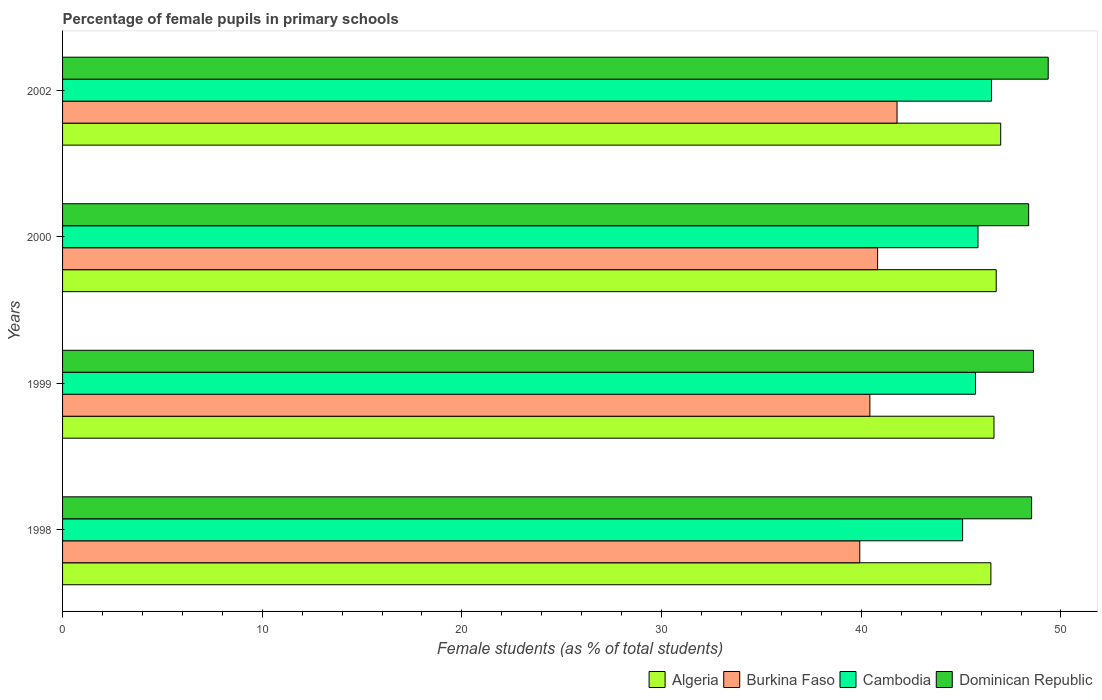How many groups of bars are there?
Your answer should be compact. 4. Are the number of bars on each tick of the Y-axis equal?
Your response must be concise. Yes. How many bars are there on the 2nd tick from the bottom?
Your answer should be compact. 4. In how many cases, is the number of bars for a given year not equal to the number of legend labels?
Give a very brief answer. 0. What is the percentage of female pupils in primary schools in Cambodia in 1999?
Give a very brief answer. 45.72. Across all years, what is the maximum percentage of female pupils in primary schools in Algeria?
Provide a short and direct response. 46.98. Across all years, what is the minimum percentage of female pupils in primary schools in Algeria?
Make the answer very short. 46.49. In which year was the percentage of female pupils in primary schools in Cambodia maximum?
Your response must be concise. 2002. In which year was the percentage of female pupils in primary schools in Burkina Faso minimum?
Your answer should be compact. 1998. What is the total percentage of female pupils in primary schools in Burkina Faso in the graph?
Make the answer very short. 162.97. What is the difference between the percentage of female pupils in primary schools in Cambodia in 1998 and that in 2000?
Provide a succinct answer. -0.77. What is the difference between the percentage of female pupils in primary schools in Algeria in 1998 and the percentage of female pupils in primary schools in Burkina Faso in 1999?
Offer a terse response. 6.06. What is the average percentage of female pupils in primary schools in Dominican Republic per year?
Offer a very short reply. 48.72. In the year 1999, what is the difference between the percentage of female pupils in primary schools in Burkina Faso and percentage of female pupils in primary schools in Algeria?
Your answer should be very brief. -6.21. What is the ratio of the percentage of female pupils in primary schools in Burkina Faso in 1999 to that in 2002?
Provide a succinct answer. 0.97. What is the difference between the highest and the second highest percentage of female pupils in primary schools in Algeria?
Give a very brief answer. 0.23. What is the difference between the highest and the lowest percentage of female pupils in primary schools in Algeria?
Your answer should be compact. 0.49. Is the sum of the percentage of female pupils in primary schools in Cambodia in 2000 and 2002 greater than the maximum percentage of female pupils in primary schools in Algeria across all years?
Your answer should be very brief. Yes. What does the 4th bar from the top in 2002 represents?
Your response must be concise. Algeria. What does the 3rd bar from the bottom in 2002 represents?
Make the answer very short. Cambodia. Is it the case that in every year, the sum of the percentage of female pupils in primary schools in Dominican Republic and percentage of female pupils in primary schools in Burkina Faso is greater than the percentage of female pupils in primary schools in Cambodia?
Keep it short and to the point. Yes. How many bars are there?
Give a very brief answer. 16. How many years are there in the graph?
Your answer should be compact. 4. Are the values on the major ticks of X-axis written in scientific E-notation?
Make the answer very short. No. Does the graph contain any zero values?
Give a very brief answer. No. Does the graph contain grids?
Your answer should be very brief. No. Where does the legend appear in the graph?
Your answer should be compact. Bottom right. What is the title of the graph?
Offer a very short reply. Percentage of female pupils in primary schools. Does "Ethiopia" appear as one of the legend labels in the graph?
Offer a terse response. No. What is the label or title of the X-axis?
Provide a short and direct response. Female students (as % of total students). What is the Female students (as % of total students) in Algeria in 1998?
Ensure brevity in your answer.  46.49. What is the Female students (as % of total students) in Burkina Faso in 1998?
Give a very brief answer. 39.93. What is the Female students (as % of total students) of Cambodia in 1998?
Your response must be concise. 45.08. What is the Female students (as % of total students) of Dominican Republic in 1998?
Make the answer very short. 48.53. What is the Female students (as % of total students) of Algeria in 1999?
Provide a succinct answer. 46.65. What is the Female students (as % of total students) in Burkina Faso in 1999?
Provide a short and direct response. 40.43. What is the Female students (as % of total students) of Cambodia in 1999?
Keep it short and to the point. 45.72. What is the Female students (as % of total students) in Dominican Republic in 1999?
Make the answer very short. 48.62. What is the Female students (as % of total students) of Algeria in 2000?
Your response must be concise. 46.76. What is the Female students (as % of total students) of Burkina Faso in 2000?
Keep it short and to the point. 40.82. What is the Female students (as % of total students) in Cambodia in 2000?
Give a very brief answer. 45.85. What is the Female students (as % of total students) in Dominican Republic in 2000?
Make the answer very short. 48.38. What is the Female students (as % of total students) of Algeria in 2002?
Give a very brief answer. 46.98. What is the Female students (as % of total students) in Burkina Faso in 2002?
Provide a succinct answer. 41.79. What is the Female students (as % of total students) of Cambodia in 2002?
Your response must be concise. 46.52. What is the Female students (as % of total students) of Dominican Republic in 2002?
Offer a terse response. 49.36. Across all years, what is the maximum Female students (as % of total students) in Algeria?
Offer a terse response. 46.98. Across all years, what is the maximum Female students (as % of total students) in Burkina Faso?
Keep it short and to the point. 41.79. Across all years, what is the maximum Female students (as % of total students) in Cambodia?
Provide a short and direct response. 46.52. Across all years, what is the maximum Female students (as % of total students) of Dominican Republic?
Offer a very short reply. 49.36. Across all years, what is the minimum Female students (as % of total students) in Algeria?
Your answer should be very brief. 46.49. Across all years, what is the minimum Female students (as % of total students) in Burkina Faso?
Keep it short and to the point. 39.93. Across all years, what is the minimum Female students (as % of total students) of Cambodia?
Offer a very short reply. 45.08. Across all years, what is the minimum Female students (as % of total students) of Dominican Republic?
Provide a short and direct response. 48.38. What is the total Female students (as % of total students) of Algeria in the graph?
Keep it short and to the point. 186.88. What is the total Female students (as % of total students) in Burkina Faso in the graph?
Provide a short and direct response. 162.97. What is the total Female students (as % of total students) in Cambodia in the graph?
Make the answer very short. 183.17. What is the total Female students (as % of total students) of Dominican Republic in the graph?
Make the answer very short. 194.9. What is the difference between the Female students (as % of total students) in Algeria in 1998 and that in 1999?
Your answer should be compact. -0.15. What is the difference between the Female students (as % of total students) of Burkina Faso in 1998 and that in 1999?
Your answer should be compact. -0.51. What is the difference between the Female students (as % of total students) of Cambodia in 1998 and that in 1999?
Your answer should be very brief. -0.65. What is the difference between the Female students (as % of total students) in Dominican Republic in 1998 and that in 1999?
Offer a very short reply. -0.09. What is the difference between the Female students (as % of total students) of Algeria in 1998 and that in 2000?
Provide a short and direct response. -0.27. What is the difference between the Female students (as % of total students) in Burkina Faso in 1998 and that in 2000?
Offer a very short reply. -0.89. What is the difference between the Female students (as % of total students) in Cambodia in 1998 and that in 2000?
Provide a succinct answer. -0.77. What is the difference between the Female students (as % of total students) of Dominican Republic in 1998 and that in 2000?
Make the answer very short. 0.15. What is the difference between the Female students (as % of total students) of Algeria in 1998 and that in 2002?
Offer a terse response. -0.49. What is the difference between the Female students (as % of total students) in Burkina Faso in 1998 and that in 2002?
Offer a very short reply. -1.87. What is the difference between the Female students (as % of total students) of Cambodia in 1998 and that in 2002?
Offer a very short reply. -1.45. What is the difference between the Female students (as % of total students) of Dominican Republic in 1998 and that in 2002?
Offer a terse response. -0.83. What is the difference between the Female students (as % of total students) in Algeria in 1999 and that in 2000?
Offer a terse response. -0.11. What is the difference between the Female students (as % of total students) in Burkina Faso in 1999 and that in 2000?
Provide a succinct answer. -0.39. What is the difference between the Female students (as % of total students) in Cambodia in 1999 and that in 2000?
Ensure brevity in your answer.  -0.12. What is the difference between the Female students (as % of total students) of Dominican Republic in 1999 and that in 2000?
Provide a succinct answer. 0.24. What is the difference between the Female students (as % of total students) in Algeria in 1999 and that in 2002?
Give a very brief answer. -0.34. What is the difference between the Female students (as % of total students) of Burkina Faso in 1999 and that in 2002?
Provide a short and direct response. -1.36. What is the difference between the Female students (as % of total students) of Cambodia in 1999 and that in 2002?
Keep it short and to the point. -0.8. What is the difference between the Female students (as % of total students) in Dominican Republic in 1999 and that in 2002?
Your answer should be very brief. -0.74. What is the difference between the Female students (as % of total students) of Algeria in 2000 and that in 2002?
Your answer should be compact. -0.23. What is the difference between the Female students (as % of total students) in Burkina Faso in 2000 and that in 2002?
Keep it short and to the point. -0.97. What is the difference between the Female students (as % of total students) of Cambodia in 2000 and that in 2002?
Offer a terse response. -0.68. What is the difference between the Female students (as % of total students) of Dominican Republic in 2000 and that in 2002?
Offer a terse response. -0.98. What is the difference between the Female students (as % of total students) of Algeria in 1998 and the Female students (as % of total students) of Burkina Faso in 1999?
Provide a succinct answer. 6.06. What is the difference between the Female students (as % of total students) of Algeria in 1998 and the Female students (as % of total students) of Cambodia in 1999?
Give a very brief answer. 0.77. What is the difference between the Female students (as % of total students) in Algeria in 1998 and the Female students (as % of total students) in Dominican Republic in 1999?
Keep it short and to the point. -2.13. What is the difference between the Female students (as % of total students) of Burkina Faso in 1998 and the Female students (as % of total students) of Cambodia in 1999?
Keep it short and to the point. -5.8. What is the difference between the Female students (as % of total students) of Burkina Faso in 1998 and the Female students (as % of total students) of Dominican Republic in 1999?
Your answer should be compact. -8.7. What is the difference between the Female students (as % of total students) in Cambodia in 1998 and the Female students (as % of total students) in Dominican Republic in 1999?
Provide a succinct answer. -3.55. What is the difference between the Female students (as % of total students) of Algeria in 1998 and the Female students (as % of total students) of Burkina Faso in 2000?
Your answer should be compact. 5.67. What is the difference between the Female students (as % of total students) of Algeria in 1998 and the Female students (as % of total students) of Cambodia in 2000?
Provide a succinct answer. 0.65. What is the difference between the Female students (as % of total students) in Algeria in 1998 and the Female students (as % of total students) in Dominican Republic in 2000?
Keep it short and to the point. -1.89. What is the difference between the Female students (as % of total students) in Burkina Faso in 1998 and the Female students (as % of total students) in Cambodia in 2000?
Give a very brief answer. -5.92. What is the difference between the Female students (as % of total students) of Burkina Faso in 1998 and the Female students (as % of total students) of Dominican Republic in 2000?
Give a very brief answer. -8.46. What is the difference between the Female students (as % of total students) in Cambodia in 1998 and the Female students (as % of total students) in Dominican Republic in 2000?
Your answer should be very brief. -3.31. What is the difference between the Female students (as % of total students) of Algeria in 1998 and the Female students (as % of total students) of Burkina Faso in 2002?
Provide a succinct answer. 4.7. What is the difference between the Female students (as % of total students) of Algeria in 1998 and the Female students (as % of total students) of Cambodia in 2002?
Offer a very short reply. -0.03. What is the difference between the Female students (as % of total students) in Algeria in 1998 and the Female students (as % of total students) in Dominican Republic in 2002?
Offer a very short reply. -2.87. What is the difference between the Female students (as % of total students) in Burkina Faso in 1998 and the Female students (as % of total students) in Cambodia in 2002?
Give a very brief answer. -6.6. What is the difference between the Female students (as % of total students) in Burkina Faso in 1998 and the Female students (as % of total students) in Dominican Republic in 2002?
Offer a very short reply. -9.44. What is the difference between the Female students (as % of total students) in Cambodia in 1998 and the Female students (as % of total students) in Dominican Republic in 2002?
Offer a terse response. -4.29. What is the difference between the Female students (as % of total students) of Algeria in 1999 and the Female students (as % of total students) of Burkina Faso in 2000?
Your answer should be very brief. 5.83. What is the difference between the Female students (as % of total students) in Algeria in 1999 and the Female students (as % of total students) in Cambodia in 2000?
Keep it short and to the point. 0.8. What is the difference between the Female students (as % of total students) in Algeria in 1999 and the Female students (as % of total students) in Dominican Republic in 2000?
Make the answer very short. -1.74. What is the difference between the Female students (as % of total students) in Burkina Faso in 1999 and the Female students (as % of total students) in Cambodia in 2000?
Your answer should be compact. -5.41. What is the difference between the Female students (as % of total students) in Burkina Faso in 1999 and the Female students (as % of total students) in Dominican Republic in 2000?
Make the answer very short. -7.95. What is the difference between the Female students (as % of total students) in Cambodia in 1999 and the Female students (as % of total students) in Dominican Republic in 2000?
Keep it short and to the point. -2.66. What is the difference between the Female students (as % of total students) in Algeria in 1999 and the Female students (as % of total students) in Burkina Faso in 2002?
Give a very brief answer. 4.85. What is the difference between the Female students (as % of total students) in Algeria in 1999 and the Female students (as % of total students) in Cambodia in 2002?
Provide a succinct answer. 0.12. What is the difference between the Female students (as % of total students) of Algeria in 1999 and the Female students (as % of total students) of Dominican Republic in 2002?
Offer a very short reply. -2.72. What is the difference between the Female students (as % of total students) of Burkina Faso in 1999 and the Female students (as % of total students) of Cambodia in 2002?
Ensure brevity in your answer.  -6.09. What is the difference between the Female students (as % of total students) of Burkina Faso in 1999 and the Female students (as % of total students) of Dominican Republic in 2002?
Provide a succinct answer. -8.93. What is the difference between the Female students (as % of total students) in Cambodia in 1999 and the Female students (as % of total students) in Dominican Republic in 2002?
Keep it short and to the point. -3.64. What is the difference between the Female students (as % of total students) of Algeria in 2000 and the Female students (as % of total students) of Burkina Faso in 2002?
Your response must be concise. 4.97. What is the difference between the Female students (as % of total students) of Algeria in 2000 and the Female students (as % of total students) of Cambodia in 2002?
Make the answer very short. 0.24. What is the difference between the Female students (as % of total students) of Algeria in 2000 and the Female students (as % of total students) of Dominican Republic in 2002?
Ensure brevity in your answer.  -2.6. What is the difference between the Female students (as % of total students) in Burkina Faso in 2000 and the Female students (as % of total students) in Cambodia in 2002?
Offer a terse response. -5.7. What is the difference between the Female students (as % of total students) of Burkina Faso in 2000 and the Female students (as % of total students) of Dominican Republic in 2002?
Your answer should be compact. -8.54. What is the difference between the Female students (as % of total students) in Cambodia in 2000 and the Female students (as % of total students) in Dominican Republic in 2002?
Make the answer very short. -3.52. What is the average Female students (as % of total students) in Algeria per year?
Ensure brevity in your answer.  46.72. What is the average Female students (as % of total students) in Burkina Faso per year?
Your response must be concise. 40.74. What is the average Female students (as % of total students) in Cambodia per year?
Ensure brevity in your answer.  45.79. What is the average Female students (as % of total students) in Dominican Republic per year?
Your answer should be very brief. 48.72. In the year 1998, what is the difference between the Female students (as % of total students) of Algeria and Female students (as % of total students) of Burkina Faso?
Your answer should be compact. 6.57. In the year 1998, what is the difference between the Female students (as % of total students) of Algeria and Female students (as % of total students) of Cambodia?
Keep it short and to the point. 1.42. In the year 1998, what is the difference between the Female students (as % of total students) in Algeria and Female students (as % of total students) in Dominican Republic?
Give a very brief answer. -2.04. In the year 1998, what is the difference between the Female students (as % of total students) in Burkina Faso and Female students (as % of total students) in Cambodia?
Ensure brevity in your answer.  -5.15. In the year 1998, what is the difference between the Female students (as % of total students) of Burkina Faso and Female students (as % of total students) of Dominican Republic?
Offer a very short reply. -8.61. In the year 1998, what is the difference between the Female students (as % of total students) of Cambodia and Female students (as % of total students) of Dominican Republic?
Keep it short and to the point. -3.45. In the year 1999, what is the difference between the Female students (as % of total students) in Algeria and Female students (as % of total students) in Burkina Faso?
Make the answer very short. 6.21. In the year 1999, what is the difference between the Female students (as % of total students) of Algeria and Female students (as % of total students) of Cambodia?
Your answer should be very brief. 0.92. In the year 1999, what is the difference between the Female students (as % of total students) in Algeria and Female students (as % of total students) in Dominican Republic?
Offer a very short reply. -1.98. In the year 1999, what is the difference between the Female students (as % of total students) in Burkina Faso and Female students (as % of total students) in Cambodia?
Ensure brevity in your answer.  -5.29. In the year 1999, what is the difference between the Female students (as % of total students) of Burkina Faso and Female students (as % of total students) of Dominican Republic?
Keep it short and to the point. -8.19. In the year 1999, what is the difference between the Female students (as % of total students) in Cambodia and Female students (as % of total students) in Dominican Republic?
Ensure brevity in your answer.  -2.9. In the year 2000, what is the difference between the Female students (as % of total students) in Algeria and Female students (as % of total students) in Burkina Faso?
Give a very brief answer. 5.94. In the year 2000, what is the difference between the Female students (as % of total students) of Algeria and Female students (as % of total students) of Cambodia?
Provide a short and direct response. 0.91. In the year 2000, what is the difference between the Female students (as % of total students) of Algeria and Female students (as % of total students) of Dominican Republic?
Offer a very short reply. -1.62. In the year 2000, what is the difference between the Female students (as % of total students) of Burkina Faso and Female students (as % of total students) of Cambodia?
Ensure brevity in your answer.  -5.03. In the year 2000, what is the difference between the Female students (as % of total students) in Burkina Faso and Female students (as % of total students) in Dominican Republic?
Offer a very short reply. -7.56. In the year 2000, what is the difference between the Female students (as % of total students) in Cambodia and Female students (as % of total students) in Dominican Republic?
Offer a very short reply. -2.54. In the year 2002, what is the difference between the Female students (as % of total students) of Algeria and Female students (as % of total students) of Burkina Faso?
Make the answer very short. 5.19. In the year 2002, what is the difference between the Female students (as % of total students) in Algeria and Female students (as % of total students) in Cambodia?
Provide a succinct answer. 0.46. In the year 2002, what is the difference between the Female students (as % of total students) in Algeria and Female students (as % of total students) in Dominican Republic?
Ensure brevity in your answer.  -2.38. In the year 2002, what is the difference between the Female students (as % of total students) of Burkina Faso and Female students (as % of total students) of Cambodia?
Make the answer very short. -4.73. In the year 2002, what is the difference between the Female students (as % of total students) of Burkina Faso and Female students (as % of total students) of Dominican Republic?
Ensure brevity in your answer.  -7.57. In the year 2002, what is the difference between the Female students (as % of total students) of Cambodia and Female students (as % of total students) of Dominican Republic?
Make the answer very short. -2.84. What is the ratio of the Female students (as % of total students) of Algeria in 1998 to that in 1999?
Offer a terse response. 1. What is the ratio of the Female students (as % of total students) of Burkina Faso in 1998 to that in 1999?
Offer a terse response. 0.99. What is the ratio of the Female students (as % of total students) in Cambodia in 1998 to that in 1999?
Your response must be concise. 0.99. What is the ratio of the Female students (as % of total students) of Burkina Faso in 1998 to that in 2000?
Offer a very short reply. 0.98. What is the ratio of the Female students (as % of total students) of Cambodia in 1998 to that in 2000?
Your answer should be very brief. 0.98. What is the ratio of the Female students (as % of total students) of Dominican Republic in 1998 to that in 2000?
Ensure brevity in your answer.  1. What is the ratio of the Female students (as % of total students) of Algeria in 1998 to that in 2002?
Provide a succinct answer. 0.99. What is the ratio of the Female students (as % of total students) in Burkina Faso in 1998 to that in 2002?
Provide a short and direct response. 0.96. What is the ratio of the Female students (as % of total students) of Cambodia in 1998 to that in 2002?
Your answer should be compact. 0.97. What is the ratio of the Female students (as % of total students) of Dominican Republic in 1998 to that in 2002?
Give a very brief answer. 0.98. What is the ratio of the Female students (as % of total students) of Burkina Faso in 1999 to that in 2000?
Provide a succinct answer. 0.99. What is the ratio of the Female students (as % of total students) in Cambodia in 1999 to that in 2000?
Offer a terse response. 1. What is the ratio of the Female students (as % of total students) of Dominican Republic in 1999 to that in 2000?
Provide a short and direct response. 1. What is the ratio of the Female students (as % of total students) in Algeria in 1999 to that in 2002?
Ensure brevity in your answer.  0.99. What is the ratio of the Female students (as % of total students) of Burkina Faso in 1999 to that in 2002?
Your answer should be compact. 0.97. What is the ratio of the Female students (as % of total students) of Cambodia in 1999 to that in 2002?
Provide a succinct answer. 0.98. What is the ratio of the Female students (as % of total students) in Dominican Republic in 1999 to that in 2002?
Give a very brief answer. 0.98. What is the ratio of the Female students (as % of total students) in Algeria in 2000 to that in 2002?
Keep it short and to the point. 1. What is the ratio of the Female students (as % of total students) of Burkina Faso in 2000 to that in 2002?
Your answer should be very brief. 0.98. What is the ratio of the Female students (as % of total students) in Cambodia in 2000 to that in 2002?
Your answer should be very brief. 0.99. What is the ratio of the Female students (as % of total students) in Dominican Republic in 2000 to that in 2002?
Provide a succinct answer. 0.98. What is the difference between the highest and the second highest Female students (as % of total students) in Algeria?
Keep it short and to the point. 0.23. What is the difference between the highest and the second highest Female students (as % of total students) in Burkina Faso?
Provide a short and direct response. 0.97. What is the difference between the highest and the second highest Female students (as % of total students) in Cambodia?
Give a very brief answer. 0.68. What is the difference between the highest and the second highest Female students (as % of total students) of Dominican Republic?
Ensure brevity in your answer.  0.74. What is the difference between the highest and the lowest Female students (as % of total students) of Algeria?
Make the answer very short. 0.49. What is the difference between the highest and the lowest Female students (as % of total students) of Burkina Faso?
Your answer should be compact. 1.87. What is the difference between the highest and the lowest Female students (as % of total students) in Cambodia?
Your answer should be compact. 1.45. 